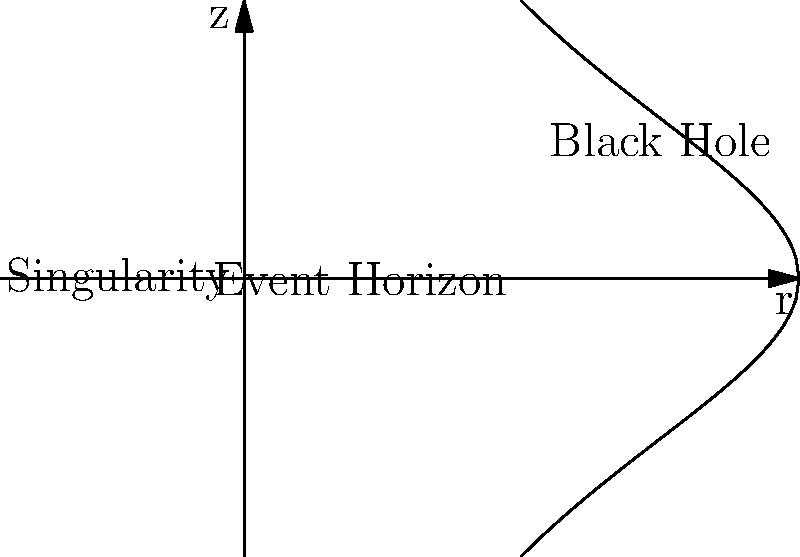In the diagram of a black hole's structure, what does the curved line represent, and how does it relate to the concept of the event horizon in Information Technology security? 1. The curved line in the diagram represents the event horizon of a black hole.

2. In a black hole, the event horizon is the boundary beyond which nothing, not even light, can escape due to the intense gravitational pull.

3. This concept can be related to Information Technology security in the following ways:

   a. Data Security: Just as information cannot escape a black hole once it crosses the event horizon, sensitive data should not be able to "escape" a secure system without proper authorization.

   b. Point of No Return: In both cases, there's a critical point (event horizon) beyond which recovery or retrieval becomes impossible.

   c. Perimeter Security: The event horizon acts as a perimeter in space, similar to how firewalls and intrusion detection systems create a security perimeter in IT networks.

   d. Information Loss: Information that crosses a black hole's event horizon is effectively lost, which parallels the concept of data loss prevention in IT security.

4. Understanding this analogy can help IT professionals working in law enforcement to conceptualize and implement robust security measures, ensuring that sensitive information remains protected within the system's "event horizon."
Answer: Event horizon; represents the boundary of no return in both black holes and IT security systems. 